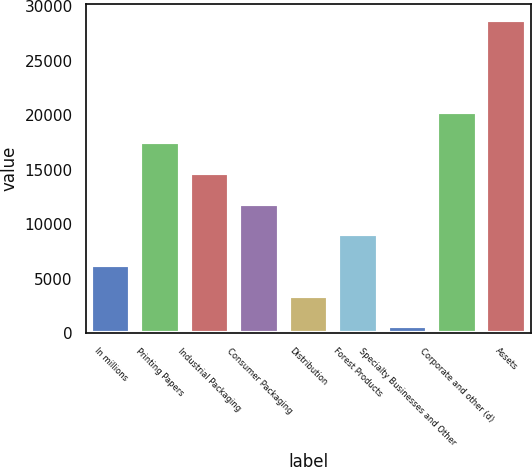Convert chart to OTSL. <chart><loc_0><loc_0><loc_500><loc_500><bar_chart><fcel>In millions<fcel>Printing Papers<fcel>Industrial Packaging<fcel>Consumer Packaging<fcel>Distribution<fcel>Forest Products<fcel>Specialty Businesses and Other<fcel>Corporate and other (d)<fcel>Assets<nl><fcel>6275.8<fcel>17523.4<fcel>14711.5<fcel>11899.6<fcel>3463.9<fcel>9087.7<fcel>652<fcel>20335.3<fcel>28771<nl></chart> 